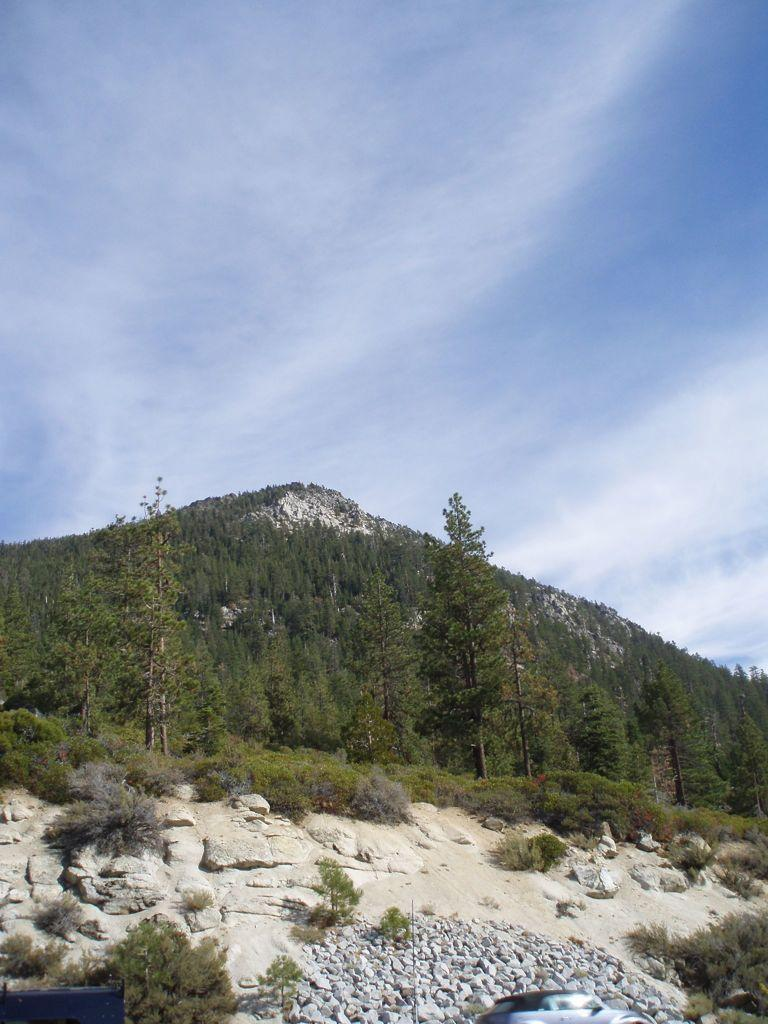What can be seen in the center of the image? The sky is visible in the center of the image. What is present in the sky? Clouds are present in the image. What type of natural elements can be seen in the image? Trees, plants, and stones are in the image. How many vehicles are in the image? There is one vehicle in the image. What type of terrain is visible in the image? There is a hill in the image. What color object is in the image? There is a black color object in the image. How many feet are visible in the image? There are no feet visible in the image. What type of chalk can be seen being used in the image? There is no chalk present in the image. 